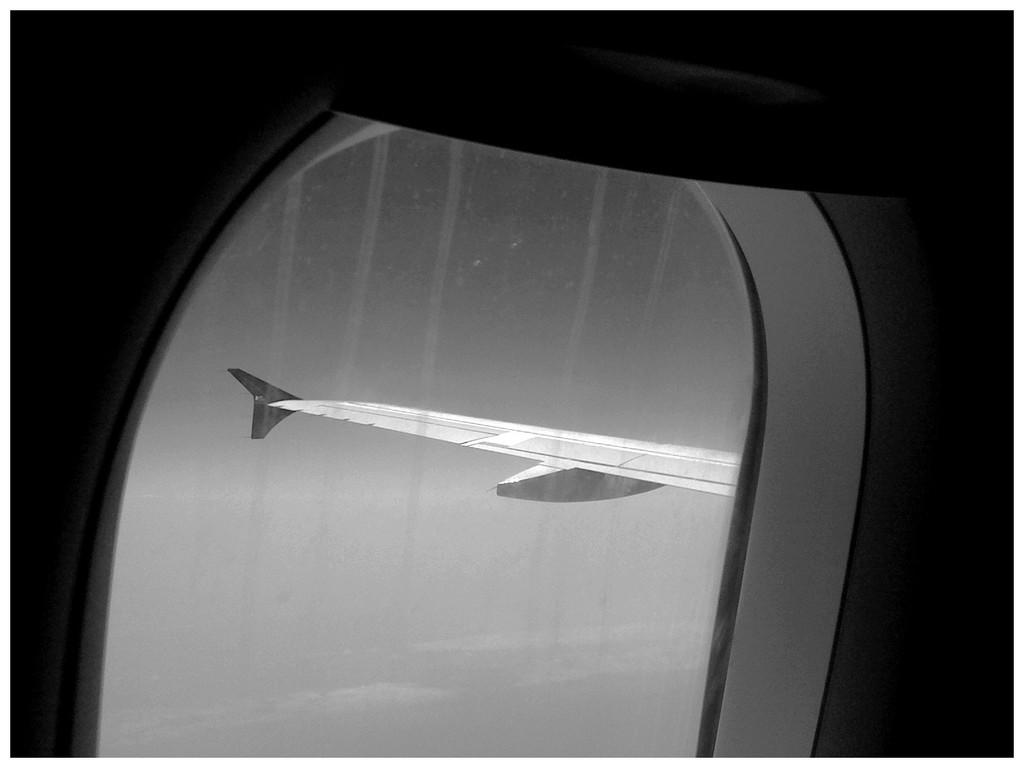What can be seen through the window in the image? The wing of an airplane is visible through the window. What is the condition of the sky in the image? The sky is clear in the image. What type of juice is being served on the table in the image? There is no table or juice present in the image; it only features a window with an airplane wing visible through it and a clear sky. 